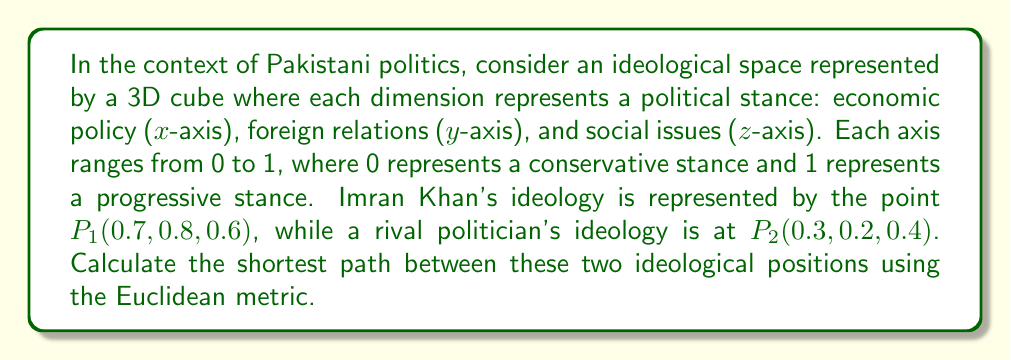Can you solve this math problem? To solve this problem, we need to use the Euclidean distance formula in three-dimensional space. The formula is:

$$d = \sqrt{(x_2-x_1)^2 + (y_2-y_1)^2 + (z_2-z_1)^2}$$

Where $(x_1, y_1, z_1)$ are the coordinates of the first point and $(x_2, y_2, z_2)$ are the coordinates of the second point.

Let's substitute the values:

$P_1(x_1, y_1, z_1) = (0.7, 0.8, 0.6)$
$P_2(x_2, y_2, z_2) = (0.3, 0.2, 0.4)$

Now, let's calculate each term inside the square root:

$(x_2-x_1)^2 = (0.3-0.7)^2 = (-0.4)^2 = 0.16$
$(y_2-y_1)^2 = (0.2-0.8)^2 = (-0.6)^2 = 0.36$
$(z_2-z_1)^2 = (0.4-0.6)^2 = (-0.2)^2 = 0.04$

Sum these terms:

$0.16 + 0.36 + 0.04 = 0.56$

Now, take the square root:

$d = \sqrt{0.56} \approx 0.7483$

This value represents the shortest path between the two ideological positions in the given 3D ideological space.
Answer: The shortest path between Imran Khan's ideological position and the rival politician's position in the given 3D ideological space is approximately 0.7483 units. 